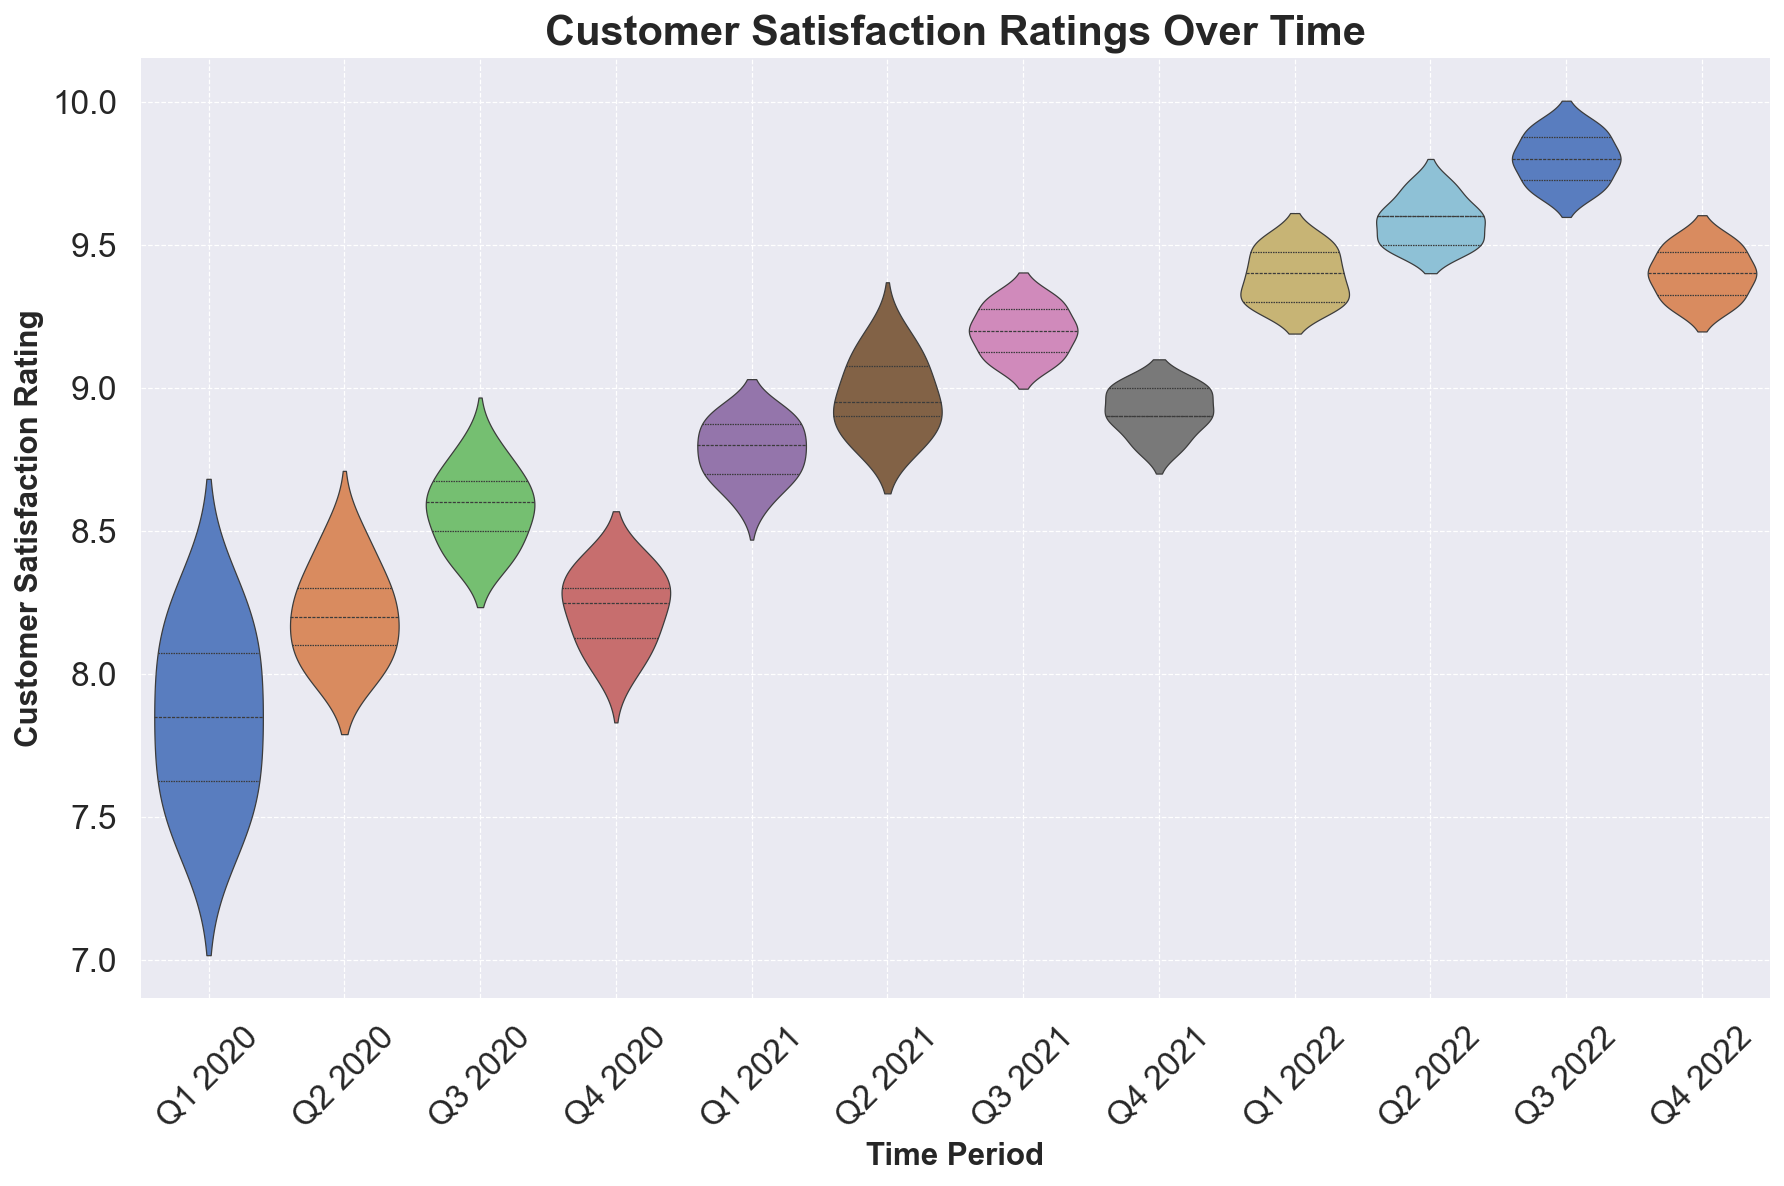How does customer satisfaction in Q1 2020 compare to Q1 2022? In the violin plot, compare the distribution of customer satisfaction ratings for Q1 2020 and Q1 2022. The mean and median for Q1 2022 are higher than those for Q1 2020.
Answer: Q1 2022 is higher Which time period shows the highest median satisfaction rating? Observe the central line in each violin plot that represents the median. The highest median occurs in Q3 2022.
Answer: Q3 2022 Is the variability in customer satisfaction higher in Q1 2020 or in Q3 2020? Look at the width and spread of the violin plots. Q1 2020 shows more variability compared to Q3 2020, which has a tighter distribution.
Answer: Q1 2020 How do Q2 2020 and Q4 2020 compare in terms of the spread of customer satisfaction ratings? Compare the width of the violin plots. Both Q2 2020 and Q4 2020 have similarly narrow spreads, indicating low variability.
Answer: Similar spread What can be said about the trend in customer satisfaction from Q1 2020 to Q3 2022? Observe the progression of the violin plots over time. There is a clear upward trend in customer satisfaction ratings from Q1 2020 to Q3 2022.
Answer: Upward trend Which time period has the least amount of variability in customer satisfaction ratings? Find the violin plot that is the narrowest. Q3 2020 has the least amount of variability.
Answer: Q3 2020 In which time period do we see the lowest median customer satisfaction rating? Look for the central line in each violin plot that represents the median. The lowest median is in Q1 2020.
Answer: Q1 2020 How do Q3 2021 and Q4 2021 compare in terms of customer satisfaction ratings? Compare the central tendency and spread of the violin plots. Both have similar means and medians, but Q3 2021 has slightly higher values overall.
Answer: Q3 2021 higher What happens to customer satisfaction ratings from Q4 2021 to Q1 2022? Observe the change in the violin plots. The median and overall customer satisfaction ratings increase from Q4 2021 to Q1 2022.
Answer: Increase 